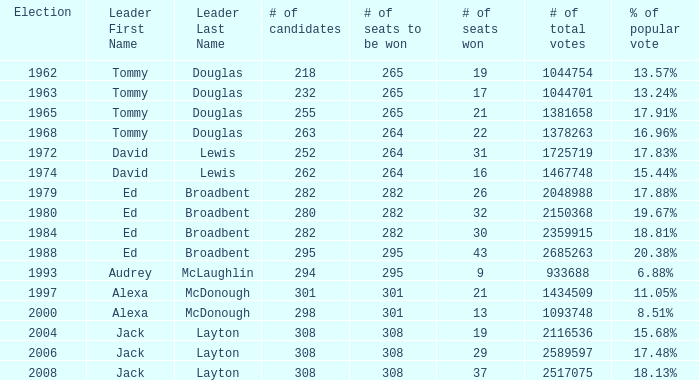Name the number of total votes for # of seats won being 30 2359915.0. 